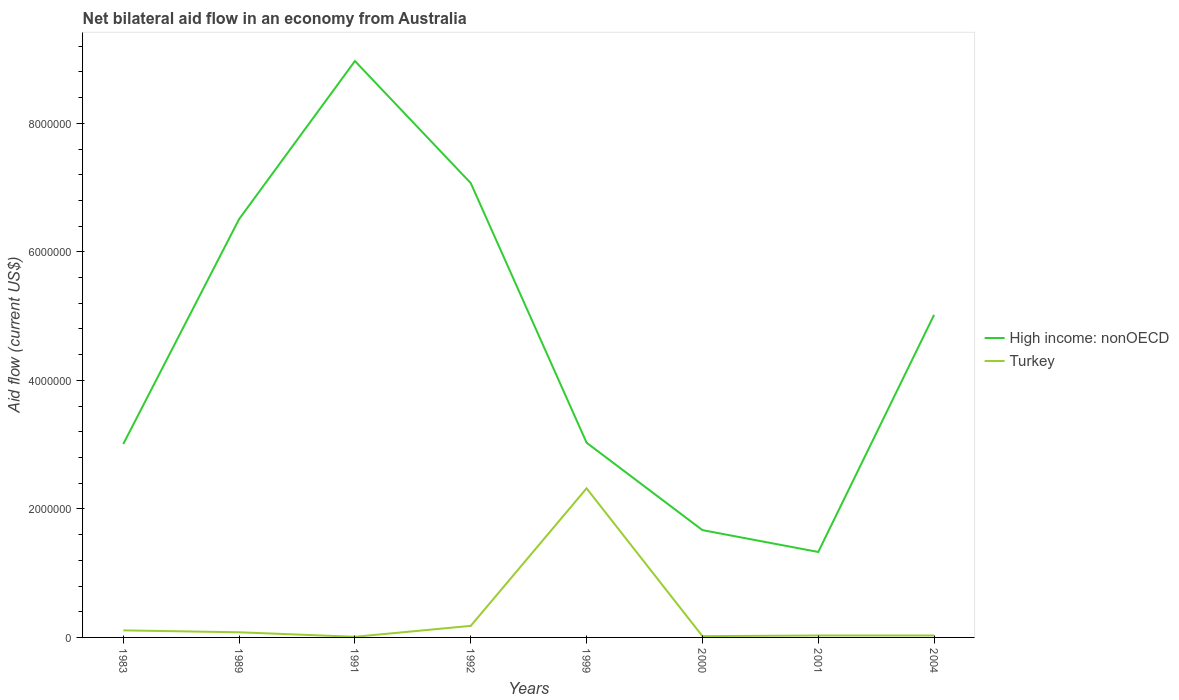In which year was the net bilateral aid flow in High income: nonOECD maximum?
Ensure brevity in your answer.  2001. What is the total net bilateral aid flow in High income: nonOECD in the graph?
Offer a very short reply. 1.34e+06. What is the difference between the highest and the second highest net bilateral aid flow in Turkey?
Your response must be concise. 2.31e+06. How many years are there in the graph?
Offer a terse response. 8. What is the difference between two consecutive major ticks on the Y-axis?
Provide a succinct answer. 2.00e+06. Does the graph contain any zero values?
Ensure brevity in your answer.  No. Where does the legend appear in the graph?
Give a very brief answer. Center right. How many legend labels are there?
Ensure brevity in your answer.  2. What is the title of the graph?
Make the answer very short. Net bilateral aid flow in an economy from Australia. What is the label or title of the X-axis?
Your response must be concise. Years. What is the label or title of the Y-axis?
Provide a succinct answer. Aid flow (current US$). What is the Aid flow (current US$) of High income: nonOECD in 1983?
Your answer should be compact. 3.01e+06. What is the Aid flow (current US$) in High income: nonOECD in 1989?
Provide a short and direct response. 6.51e+06. What is the Aid flow (current US$) in Turkey in 1989?
Provide a succinct answer. 8.00e+04. What is the Aid flow (current US$) of High income: nonOECD in 1991?
Provide a succinct answer. 8.97e+06. What is the Aid flow (current US$) of High income: nonOECD in 1992?
Keep it short and to the point. 7.07e+06. What is the Aid flow (current US$) in Turkey in 1992?
Ensure brevity in your answer.  1.80e+05. What is the Aid flow (current US$) in High income: nonOECD in 1999?
Offer a terse response. 3.03e+06. What is the Aid flow (current US$) in Turkey in 1999?
Your response must be concise. 2.32e+06. What is the Aid flow (current US$) of High income: nonOECD in 2000?
Ensure brevity in your answer.  1.67e+06. What is the Aid flow (current US$) of Turkey in 2000?
Keep it short and to the point. 2.00e+04. What is the Aid flow (current US$) in High income: nonOECD in 2001?
Provide a succinct answer. 1.33e+06. What is the Aid flow (current US$) of High income: nonOECD in 2004?
Give a very brief answer. 5.02e+06. Across all years, what is the maximum Aid flow (current US$) of High income: nonOECD?
Offer a terse response. 8.97e+06. Across all years, what is the maximum Aid flow (current US$) of Turkey?
Provide a short and direct response. 2.32e+06. Across all years, what is the minimum Aid flow (current US$) of High income: nonOECD?
Your answer should be compact. 1.33e+06. Across all years, what is the minimum Aid flow (current US$) of Turkey?
Your response must be concise. 10000. What is the total Aid flow (current US$) of High income: nonOECD in the graph?
Make the answer very short. 3.66e+07. What is the total Aid flow (current US$) in Turkey in the graph?
Provide a succinct answer. 2.78e+06. What is the difference between the Aid flow (current US$) in High income: nonOECD in 1983 and that in 1989?
Your response must be concise. -3.50e+06. What is the difference between the Aid flow (current US$) of Turkey in 1983 and that in 1989?
Your response must be concise. 3.00e+04. What is the difference between the Aid flow (current US$) of High income: nonOECD in 1983 and that in 1991?
Your answer should be compact. -5.96e+06. What is the difference between the Aid flow (current US$) in Turkey in 1983 and that in 1991?
Offer a very short reply. 1.00e+05. What is the difference between the Aid flow (current US$) in High income: nonOECD in 1983 and that in 1992?
Offer a terse response. -4.06e+06. What is the difference between the Aid flow (current US$) of Turkey in 1983 and that in 1999?
Make the answer very short. -2.21e+06. What is the difference between the Aid flow (current US$) of High income: nonOECD in 1983 and that in 2000?
Offer a terse response. 1.34e+06. What is the difference between the Aid flow (current US$) of High income: nonOECD in 1983 and that in 2001?
Provide a succinct answer. 1.68e+06. What is the difference between the Aid flow (current US$) in Turkey in 1983 and that in 2001?
Offer a very short reply. 8.00e+04. What is the difference between the Aid flow (current US$) in High income: nonOECD in 1983 and that in 2004?
Make the answer very short. -2.01e+06. What is the difference between the Aid flow (current US$) of High income: nonOECD in 1989 and that in 1991?
Offer a very short reply. -2.46e+06. What is the difference between the Aid flow (current US$) of High income: nonOECD in 1989 and that in 1992?
Your response must be concise. -5.60e+05. What is the difference between the Aid flow (current US$) of Turkey in 1989 and that in 1992?
Provide a succinct answer. -1.00e+05. What is the difference between the Aid flow (current US$) in High income: nonOECD in 1989 and that in 1999?
Ensure brevity in your answer.  3.48e+06. What is the difference between the Aid flow (current US$) of Turkey in 1989 and that in 1999?
Offer a terse response. -2.24e+06. What is the difference between the Aid flow (current US$) of High income: nonOECD in 1989 and that in 2000?
Keep it short and to the point. 4.84e+06. What is the difference between the Aid flow (current US$) of High income: nonOECD in 1989 and that in 2001?
Offer a terse response. 5.18e+06. What is the difference between the Aid flow (current US$) of Turkey in 1989 and that in 2001?
Your response must be concise. 5.00e+04. What is the difference between the Aid flow (current US$) of High income: nonOECD in 1989 and that in 2004?
Offer a very short reply. 1.49e+06. What is the difference between the Aid flow (current US$) of High income: nonOECD in 1991 and that in 1992?
Provide a short and direct response. 1.90e+06. What is the difference between the Aid flow (current US$) in Turkey in 1991 and that in 1992?
Ensure brevity in your answer.  -1.70e+05. What is the difference between the Aid flow (current US$) in High income: nonOECD in 1991 and that in 1999?
Provide a short and direct response. 5.94e+06. What is the difference between the Aid flow (current US$) in Turkey in 1991 and that in 1999?
Provide a succinct answer. -2.31e+06. What is the difference between the Aid flow (current US$) in High income: nonOECD in 1991 and that in 2000?
Keep it short and to the point. 7.30e+06. What is the difference between the Aid flow (current US$) of Turkey in 1991 and that in 2000?
Provide a succinct answer. -10000. What is the difference between the Aid flow (current US$) of High income: nonOECD in 1991 and that in 2001?
Offer a terse response. 7.64e+06. What is the difference between the Aid flow (current US$) of High income: nonOECD in 1991 and that in 2004?
Provide a short and direct response. 3.95e+06. What is the difference between the Aid flow (current US$) in High income: nonOECD in 1992 and that in 1999?
Provide a succinct answer. 4.04e+06. What is the difference between the Aid flow (current US$) in Turkey in 1992 and that in 1999?
Your answer should be very brief. -2.14e+06. What is the difference between the Aid flow (current US$) of High income: nonOECD in 1992 and that in 2000?
Keep it short and to the point. 5.40e+06. What is the difference between the Aid flow (current US$) of Turkey in 1992 and that in 2000?
Give a very brief answer. 1.60e+05. What is the difference between the Aid flow (current US$) in High income: nonOECD in 1992 and that in 2001?
Make the answer very short. 5.74e+06. What is the difference between the Aid flow (current US$) of High income: nonOECD in 1992 and that in 2004?
Keep it short and to the point. 2.05e+06. What is the difference between the Aid flow (current US$) of Turkey in 1992 and that in 2004?
Provide a short and direct response. 1.50e+05. What is the difference between the Aid flow (current US$) of High income: nonOECD in 1999 and that in 2000?
Your answer should be compact. 1.36e+06. What is the difference between the Aid flow (current US$) of Turkey in 1999 and that in 2000?
Your answer should be compact. 2.30e+06. What is the difference between the Aid flow (current US$) in High income: nonOECD in 1999 and that in 2001?
Your answer should be very brief. 1.70e+06. What is the difference between the Aid flow (current US$) of Turkey in 1999 and that in 2001?
Make the answer very short. 2.29e+06. What is the difference between the Aid flow (current US$) of High income: nonOECD in 1999 and that in 2004?
Make the answer very short. -1.99e+06. What is the difference between the Aid flow (current US$) of Turkey in 1999 and that in 2004?
Your answer should be very brief. 2.29e+06. What is the difference between the Aid flow (current US$) in High income: nonOECD in 2000 and that in 2001?
Ensure brevity in your answer.  3.40e+05. What is the difference between the Aid flow (current US$) of Turkey in 2000 and that in 2001?
Provide a succinct answer. -10000. What is the difference between the Aid flow (current US$) in High income: nonOECD in 2000 and that in 2004?
Offer a very short reply. -3.35e+06. What is the difference between the Aid flow (current US$) of High income: nonOECD in 2001 and that in 2004?
Make the answer very short. -3.69e+06. What is the difference between the Aid flow (current US$) of Turkey in 2001 and that in 2004?
Offer a terse response. 0. What is the difference between the Aid flow (current US$) of High income: nonOECD in 1983 and the Aid flow (current US$) of Turkey in 1989?
Your answer should be very brief. 2.93e+06. What is the difference between the Aid flow (current US$) of High income: nonOECD in 1983 and the Aid flow (current US$) of Turkey in 1991?
Make the answer very short. 3.00e+06. What is the difference between the Aid flow (current US$) of High income: nonOECD in 1983 and the Aid flow (current US$) of Turkey in 1992?
Provide a succinct answer. 2.83e+06. What is the difference between the Aid flow (current US$) of High income: nonOECD in 1983 and the Aid flow (current US$) of Turkey in 1999?
Give a very brief answer. 6.90e+05. What is the difference between the Aid flow (current US$) in High income: nonOECD in 1983 and the Aid flow (current US$) in Turkey in 2000?
Provide a short and direct response. 2.99e+06. What is the difference between the Aid flow (current US$) in High income: nonOECD in 1983 and the Aid flow (current US$) in Turkey in 2001?
Make the answer very short. 2.98e+06. What is the difference between the Aid flow (current US$) in High income: nonOECD in 1983 and the Aid flow (current US$) in Turkey in 2004?
Provide a succinct answer. 2.98e+06. What is the difference between the Aid flow (current US$) of High income: nonOECD in 1989 and the Aid flow (current US$) of Turkey in 1991?
Make the answer very short. 6.50e+06. What is the difference between the Aid flow (current US$) in High income: nonOECD in 1989 and the Aid flow (current US$) in Turkey in 1992?
Offer a very short reply. 6.33e+06. What is the difference between the Aid flow (current US$) of High income: nonOECD in 1989 and the Aid flow (current US$) of Turkey in 1999?
Your answer should be very brief. 4.19e+06. What is the difference between the Aid flow (current US$) of High income: nonOECD in 1989 and the Aid flow (current US$) of Turkey in 2000?
Your answer should be compact. 6.49e+06. What is the difference between the Aid flow (current US$) in High income: nonOECD in 1989 and the Aid flow (current US$) in Turkey in 2001?
Provide a short and direct response. 6.48e+06. What is the difference between the Aid flow (current US$) of High income: nonOECD in 1989 and the Aid flow (current US$) of Turkey in 2004?
Keep it short and to the point. 6.48e+06. What is the difference between the Aid flow (current US$) of High income: nonOECD in 1991 and the Aid flow (current US$) of Turkey in 1992?
Your answer should be very brief. 8.79e+06. What is the difference between the Aid flow (current US$) in High income: nonOECD in 1991 and the Aid flow (current US$) in Turkey in 1999?
Your answer should be compact. 6.65e+06. What is the difference between the Aid flow (current US$) of High income: nonOECD in 1991 and the Aid flow (current US$) of Turkey in 2000?
Your answer should be very brief. 8.95e+06. What is the difference between the Aid flow (current US$) in High income: nonOECD in 1991 and the Aid flow (current US$) in Turkey in 2001?
Give a very brief answer. 8.94e+06. What is the difference between the Aid flow (current US$) in High income: nonOECD in 1991 and the Aid flow (current US$) in Turkey in 2004?
Offer a very short reply. 8.94e+06. What is the difference between the Aid flow (current US$) of High income: nonOECD in 1992 and the Aid flow (current US$) of Turkey in 1999?
Give a very brief answer. 4.75e+06. What is the difference between the Aid flow (current US$) in High income: nonOECD in 1992 and the Aid flow (current US$) in Turkey in 2000?
Your response must be concise. 7.05e+06. What is the difference between the Aid flow (current US$) in High income: nonOECD in 1992 and the Aid flow (current US$) in Turkey in 2001?
Keep it short and to the point. 7.04e+06. What is the difference between the Aid flow (current US$) in High income: nonOECD in 1992 and the Aid flow (current US$) in Turkey in 2004?
Your answer should be very brief. 7.04e+06. What is the difference between the Aid flow (current US$) of High income: nonOECD in 1999 and the Aid flow (current US$) of Turkey in 2000?
Ensure brevity in your answer.  3.01e+06. What is the difference between the Aid flow (current US$) in High income: nonOECD in 2000 and the Aid flow (current US$) in Turkey in 2001?
Offer a very short reply. 1.64e+06. What is the difference between the Aid flow (current US$) in High income: nonOECD in 2000 and the Aid flow (current US$) in Turkey in 2004?
Offer a terse response. 1.64e+06. What is the difference between the Aid flow (current US$) of High income: nonOECD in 2001 and the Aid flow (current US$) of Turkey in 2004?
Give a very brief answer. 1.30e+06. What is the average Aid flow (current US$) of High income: nonOECD per year?
Ensure brevity in your answer.  4.58e+06. What is the average Aid flow (current US$) in Turkey per year?
Provide a short and direct response. 3.48e+05. In the year 1983, what is the difference between the Aid flow (current US$) in High income: nonOECD and Aid flow (current US$) in Turkey?
Ensure brevity in your answer.  2.90e+06. In the year 1989, what is the difference between the Aid flow (current US$) in High income: nonOECD and Aid flow (current US$) in Turkey?
Offer a terse response. 6.43e+06. In the year 1991, what is the difference between the Aid flow (current US$) in High income: nonOECD and Aid flow (current US$) in Turkey?
Provide a short and direct response. 8.96e+06. In the year 1992, what is the difference between the Aid flow (current US$) in High income: nonOECD and Aid flow (current US$) in Turkey?
Ensure brevity in your answer.  6.89e+06. In the year 1999, what is the difference between the Aid flow (current US$) in High income: nonOECD and Aid flow (current US$) in Turkey?
Provide a short and direct response. 7.10e+05. In the year 2000, what is the difference between the Aid flow (current US$) in High income: nonOECD and Aid flow (current US$) in Turkey?
Your response must be concise. 1.65e+06. In the year 2001, what is the difference between the Aid flow (current US$) of High income: nonOECD and Aid flow (current US$) of Turkey?
Keep it short and to the point. 1.30e+06. In the year 2004, what is the difference between the Aid flow (current US$) of High income: nonOECD and Aid flow (current US$) of Turkey?
Provide a short and direct response. 4.99e+06. What is the ratio of the Aid flow (current US$) of High income: nonOECD in 1983 to that in 1989?
Provide a succinct answer. 0.46. What is the ratio of the Aid flow (current US$) of Turkey in 1983 to that in 1989?
Offer a very short reply. 1.38. What is the ratio of the Aid flow (current US$) of High income: nonOECD in 1983 to that in 1991?
Your answer should be compact. 0.34. What is the ratio of the Aid flow (current US$) of High income: nonOECD in 1983 to that in 1992?
Make the answer very short. 0.43. What is the ratio of the Aid flow (current US$) of Turkey in 1983 to that in 1992?
Your answer should be very brief. 0.61. What is the ratio of the Aid flow (current US$) in High income: nonOECD in 1983 to that in 1999?
Your answer should be compact. 0.99. What is the ratio of the Aid flow (current US$) in Turkey in 1983 to that in 1999?
Keep it short and to the point. 0.05. What is the ratio of the Aid flow (current US$) in High income: nonOECD in 1983 to that in 2000?
Your response must be concise. 1.8. What is the ratio of the Aid flow (current US$) in Turkey in 1983 to that in 2000?
Provide a succinct answer. 5.5. What is the ratio of the Aid flow (current US$) in High income: nonOECD in 1983 to that in 2001?
Your answer should be compact. 2.26. What is the ratio of the Aid flow (current US$) in Turkey in 1983 to that in 2001?
Give a very brief answer. 3.67. What is the ratio of the Aid flow (current US$) of High income: nonOECD in 1983 to that in 2004?
Provide a succinct answer. 0.6. What is the ratio of the Aid flow (current US$) of Turkey in 1983 to that in 2004?
Your answer should be very brief. 3.67. What is the ratio of the Aid flow (current US$) in High income: nonOECD in 1989 to that in 1991?
Provide a succinct answer. 0.73. What is the ratio of the Aid flow (current US$) in Turkey in 1989 to that in 1991?
Give a very brief answer. 8. What is the ratio of the Aid flow (current US$) in High income: nonOECD in 1989 to that in 1992?
Offer a terse response. 0.92. What is the ratio of the Aid flow (current US$) of Turkey in 1989 to that in 1992?
Offer a terse response. 0.44. What is the ratio of the Aid flow (current US$) in High income: nonOECD in 1989 to that in 1999?
Offer a very short reply. 2.15. What is the ratio of the Aid flow (current US$) in Turkey in 1989 to that in 1999?
Give a very brief answer. 0.03. What is the ratio of the Aid flow (current US$) in High income: nonOECD in 1989 to that in 2000?
Your response must be concise. 3.9. What is the ratio of the Aid flow (current US$) in High income: nonOECD in 1989 to that in 2001?
Keep it short and to the point. 4.89. What is the ratio of the Aid flow (current US$) of Turkey in 1989 to that in 2001?
Make the answer very short. 2.67. What is the ratio of the Aid flow (current US$) in High income: nonOECD in 1989 to that in 2004?
Keep it short and to the point. 1.3. What is the ratio of the Aid flow (current US$) of Turkey in 1989 to that in 2004?
Provide a succinct answer. 2.67. What is the ratio of the Aid flow (current US$) in High income: nonOECD in 1991 to that in 1992?
Make the answer very short. 1.27. What is the ratio of the Aid flow (current US$) of Turkey in 1991 to that in 1992?
Give a very brief answer. 0.06. What is the ratio of the Aid flow (current US$) in High income: nonOECD in 1991 to that in 1999?
Your answer should be compact. 2.96. What is the ratio of the Aid flow (current US$) of Turkey in 1991 to that in 1999?
Your answer should be very brief. 0. What is the ratio of the Aid flow (current US$) in High income: nonOECD in 1991 to that in 2000?
Keep it short and to the point. 5.37. What is the ratio of the Aid flow (current US$) of Turkey in 1991 to that in 2000?
Give a very brief answer. 0.5. What is the ratio of the Aid flow (current US$) in High income: nonOECD in 1991 to that in 2001?
Keep it short and to the point. 6.74. What is the ratio of the Aid flow (current US$) in Turkey in 1991 to that in 2001?
Make the answer very short. 0.33. What is the ratio of the Aid flow (current US$) in High income: nonOECD in 1991 to that in 2004?
Keep it short and to the point. 1.79. What is the ratio of the Aid flow (current US$) of Turkey in 1991 to that in 2004?
Your answer should be compact. 0.33. What is the ratio of the Aid flow (current US$) of High income: nonOECD in 1992 to that in 1999?
Your answer should be very brief. 2.33. What is the ratio of the Aid flow (current US$) of Turkey in 1992 to that in 1999?
Provide a short and direct response. 0.08. What is the ratio of the Aid flow (current US$) of High income: nonOECD in 1992 to that in 2000?
Offer a terse response. 4.23. What is the ratio of the Aid flow (current US$) in Turkey in 1992 to that in 2000?
Give a very brief answer. 9. What is the ratio of the Aid flow (current US$) in High income: nonOECD in 1992 to that in 2001?
Keep it short and to the point. 5.32. What is the ratio of the Aid flow (current US$) in High income: nonOECD in 1992 to that in 2004?
Make the answer very short. 1.41. What is the ratio of the Aid flow (current US$) in High income: nonOECD in 1999 to that in 2000?
Your answer should be very brief. 1.81. What is the ratio of the Aid flow (current US$) of Turkey in 1999 to that in 2000?
Provide a succinct answer. 116. What is the ratio of the Aid flow (current US$) of High income: nonOECD in 1999 to that in 2001?
Ensure brevity in your answer.  2.28. What is the ratio of the Aid flow (current US$) of Turkey in 1999 to that in 2001?
Ensure brevity in your answer.  77.33. What is the ratio of the Aid flow (current US$) of High income: nonOECD in 1999 to that in 2004?
Provide a short and direct response. 0.6. What is the ratio of the Aid flow (current US$) of Turkey in 1999 to that in 2004?
Offer a very short reply. 77.33. What is the ratio of the Aid flow (current US$) of High income: nonOECD in 2000 to that in 2001?
Make the answer very short. 1.26. What is the ratio of the Aid flow (current US$) of Turkey in 2000 to that in 2001?
Your answer should be compact. 0.67. What is the ratio of the Aid flow (current US$) in High income: nonOECD in 2000 to that in 2004?
Give a very brief answer. 0.33. What is the ratio of the Aid flow (current US$) in High income: nonOECD in 2001 to that in 2004?
Provide a short and direct response. 0.26. What is the ratio of the Aid flow (current US$) in Turkey in 2001 to that in 2004?
Offer a very short reply. 1. What is the difference between the highest and the second highest Aid flow (current US$) in High income: nonOECD?
Offer a very short reply. 1.90e+06. What is the difference between the highest and the second highest Aid flow (current US$) in Turkey?
Your response must be concise. 2.14e+06. What is the difference between the highest and the lowest Aid flow (current US$) of High income: nonOECD?
Provide a short and direct response. 7.64e+06. What is the difference between the highest and the lowest Aid flow (current US$) in Turkey?
Provide a short and direct response. 2.31e+06. 